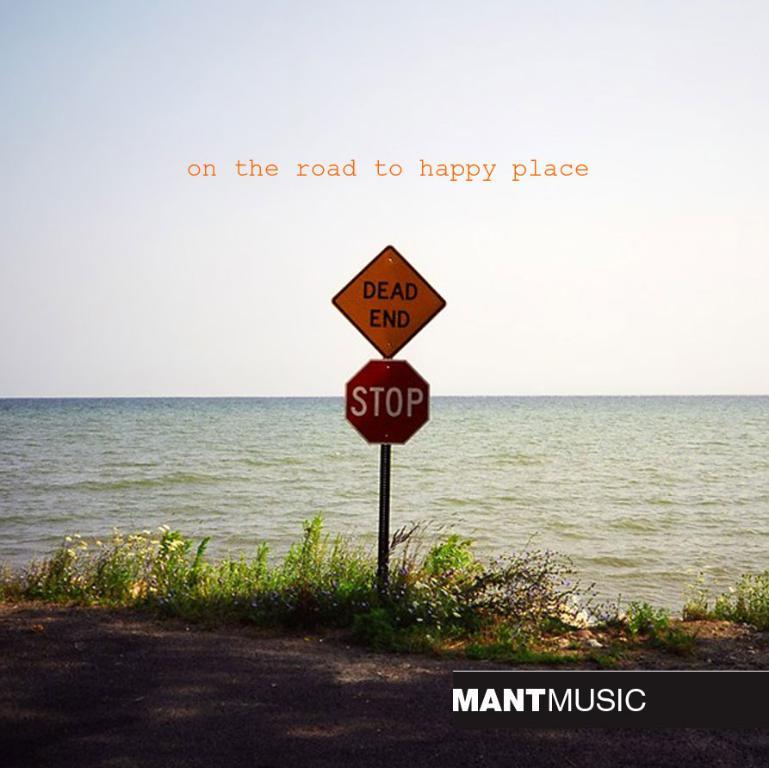What is written on some of these street signs?
Your response must be concise. Dead end, stop. What road are they on?
Your response must be concise. To happy place. 